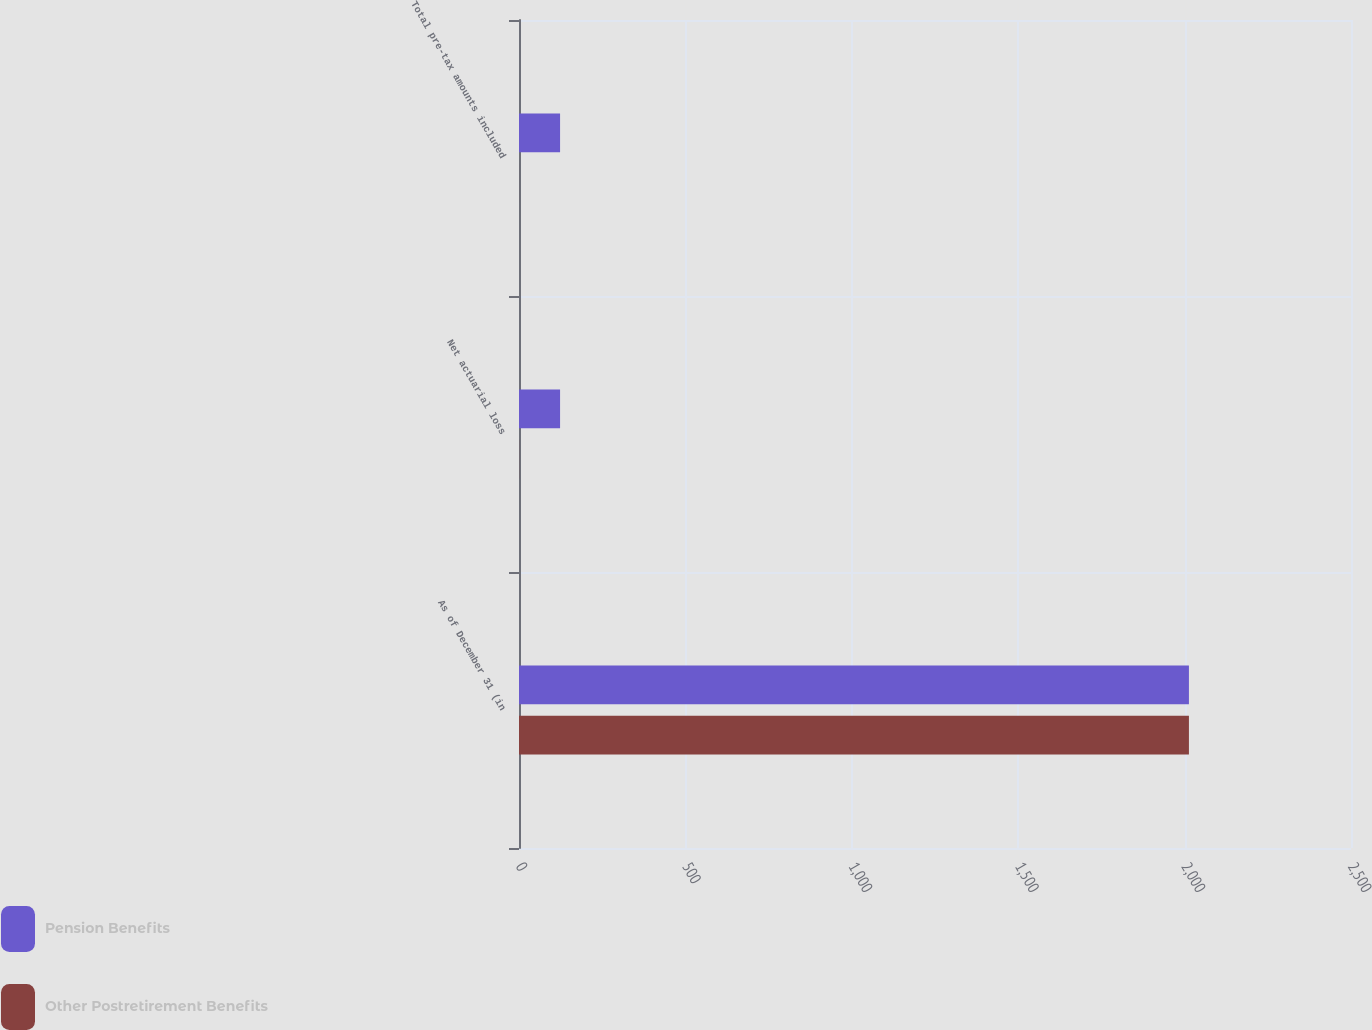Convert chart. <chart><loc_0><loc_0><loc_500><loc_500><stacked_bar_chart><ecel><fcel>As of December 31 (in<fcel>Net actuarial loss<fcel>Total pre-tax amounts included<nl><fcel>Pension Benefits<fcel>2013<fcel>123.4<fcel>123.4<nl><fcel>Other Postretirement Benefits<fcel>2013<fcel>0.3<fcel>0.1<nl></chart> 